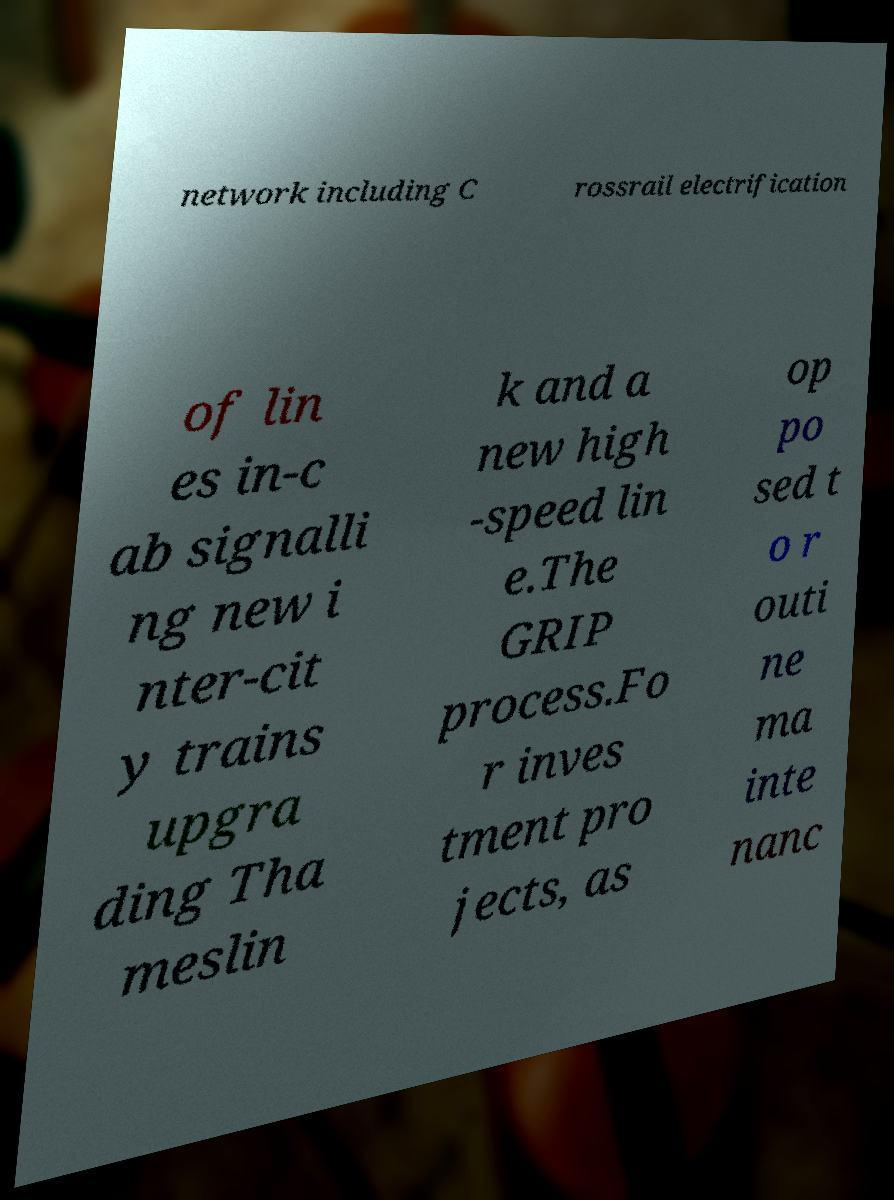Can you read and provide the text displayed in the image?This photo seems to have some interesting text. Can you extract and type it out for me? network including C rossrail electrification of lin es in-c ab signalli ng new i nter-cit y trains upgra ding Tha meslin k and a new high -speed lin e.The GRIP process.Fo r inves tment pro jects, as op po sed t o r outi ne ma inte nanc 